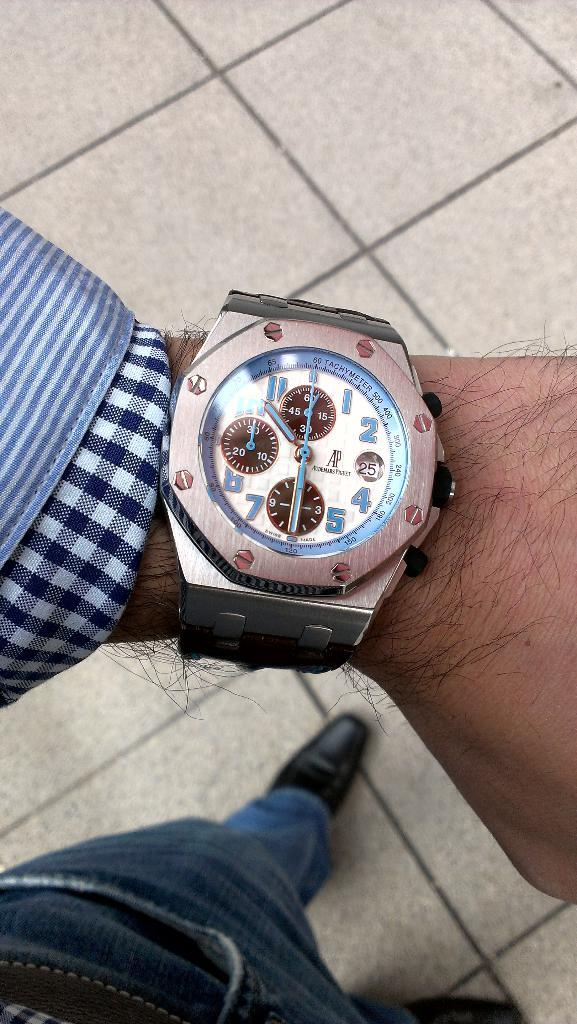<image>
Provide a brief description of the given image. A wristwatch with a tachmeter that shows the time as 10:30 is on a man's wrist . 